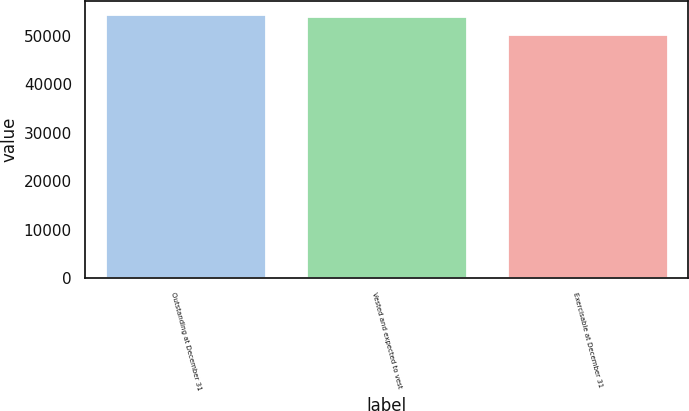Convert chart to OTSL. <chart><loc_0><loc_0><loc_500><loc_500><bar_chart><fcel>Outstanding at December 31<fcel>Vested and expected to vest<fcel>Exercisable at December 31<nl><fcel>54455.9<fcel>54083<fcel>50422<nl></chart> 